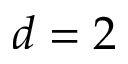<formula> <loc_0><loc_0><loc_500><loc_500>d = 2</formula> 